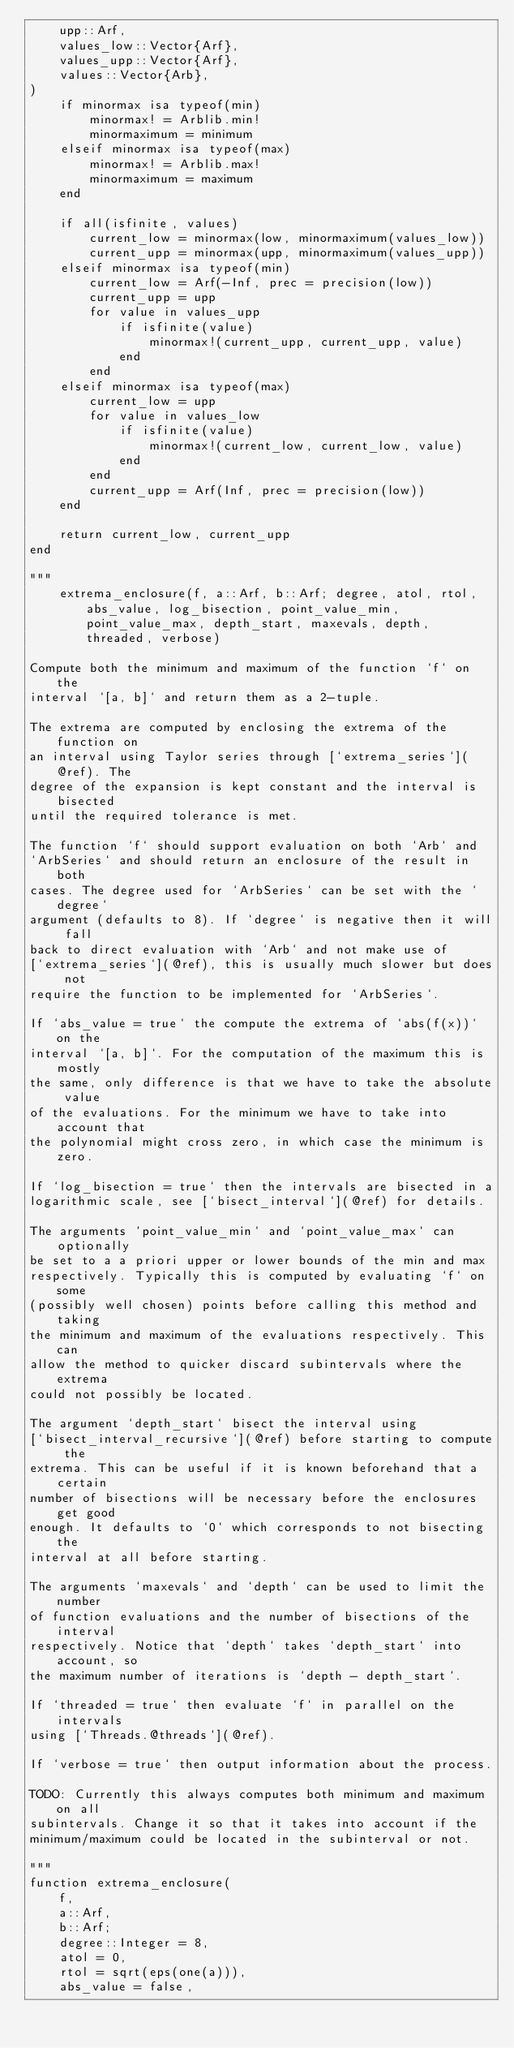<code> <loc_0><loc_0><loc_500><loc_500><_Julia_>    upp::Arf,
    values_low::Vector{Arf},
    values_upp::Vector{Arf},
    values::Vector{Arb},
)
    if minormax isa typeof(min)
        minormax! = Arblib.min!
        minormaximum = minimum
    elseif minormax isa typeof(max)
        minormax! = Arblib.max!
        minormaximum = maximum
    end

    if all(isfinite, values)
        current_low = minormax(low, minormaximum(values_low))
        current_upp = minormax(upp, minormaximum(values_upp))
    elseif minormax isa typeof(min)
        current_low = Arf(-Inf, prec = precision(low))
        current_upp = upp
        for value in values_upp
            if isfinite(value)
                minormax!(current_upp, current_upp, value)
            end
        end
    elseif minormax isa typeof(max)
        current_low = upp
        for value in values_low
            if isfinite(value)
                minormax!(current_low, current_low, value)
            end
        end
        current_upp = Arf(Inf, prec = precision(low))
    end

    return current_low, current_upp
end

"""
    extrema_enclosure(f, a::Arf, b::Arf; degree, atol, rtol, abs_value, log_bisection, point_value_min, point_value_max, depth_start, maxevals, depth, threaded, verbose)

Compute both the minimum and maximum of the function `f` on the
interval `[a, b]` and return them as a 2-tuple.

The extrema are computed by enclosing the extrema of the function on
an interval using Taylor series through [`extrema_series`](@ref). The
degree of the expansion is kept constant and the interval is bisected
until the required tolerance is met.

The function `f` should support evaluation on both `Arb` and
`ArbSeries` and should return an enclosure of the result in both
cases. The degree used for `ArbSeries` can be set with the `degree`
argument (defaults to 8). If `degree` is negative then it will fall
back to direct evaluation with `Arb` and not make use of
[`extrema_series`](@ref), this is usually much slower but does not
require the function to be implemented for `ArbSeries`.

If `abs_value = true` the compute the extrema of `abs(f(x))` on the
interval `[a, b]`. For the computation of the maximum this is mostly
the same, only difference is that we have to take the absolute value
of the evaluations. For the minimum we have to take into account that
the polynomial might cross zero, in which case the minimum is zero.

If `log_bisection = true` then the intervals are bisected in a
logarithmic scale, see [`bisect_interval`](@ref) for details.

The arguments `point_value_min` and `point_value_max` can optionally
be set to a a priori upper or lower bounds of the min and max
respectively. Typically this is computed by evaluating `f` on some
(possibly well chosen) points before calling this method and taking
the minimum and maximum of the evaluations respectively. This can
allow the method to quicker discard subintervals where the extrema
could not possibly be located.

The argument `depth_start` bisect the interval using
[`bisect_interval_recursive`](@ref) before starting to compute the
extrema. This can be useful if it is known beforehand that a certain
number of bisections will be necessary before the enclosures get good
enough. It defaults to `0` which corresponds to not bisecting the
interval at all before starting.

The arguments `maxevals` and `depth` can be used to limit the number
of function evaluations and the number of bisections of the interval
respectively. Notice that `depth` takes `depth_start` into account, so
the maximum number of iterations is `depth - depth_start`.

If `threaded = true` then evaluate `f` in parallel on the intervals
using [`Threads.@threads`](@ref).

If `verbose = true` then output information about the process.

TODO: Currently this always computes both minimum and maximum on all
subintervals. Change it so that it takes into account if the
minimum/maximum could be located in the subinterval or not.

"""
function extrema_enclosure(
    f,
    a::Arf,
    b::Arf;
    degree::Integer = 8,
    atol = 0,
    rtol = sqrt(eps(one(a))),
    abs_value = false,</code> 